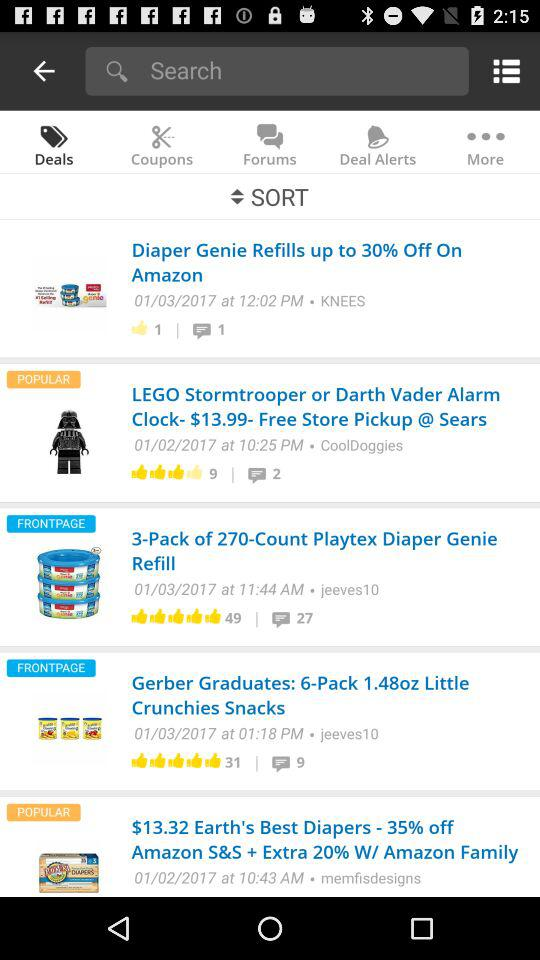How much of a discount is there on diaper genie refills? There is a 30% discount on the diaper genie refills. 